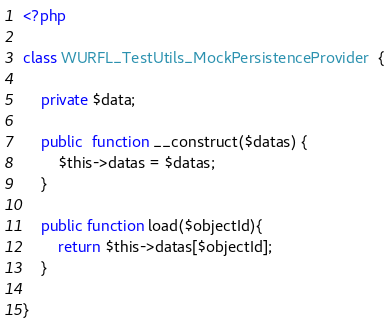Convert code to text. <code><loc_0><loc_0><loc_500><loc_500><_PHP_><?php

class WURFL_TestUtils_MockPersistenceProvider  {

	private $data;
	
	public  function __construct($datas) {
		$this->datas = $datas;
	}
	
	public function load($objectId){
		return $this->datas[$objectId];		
	}
	
}

</code> 